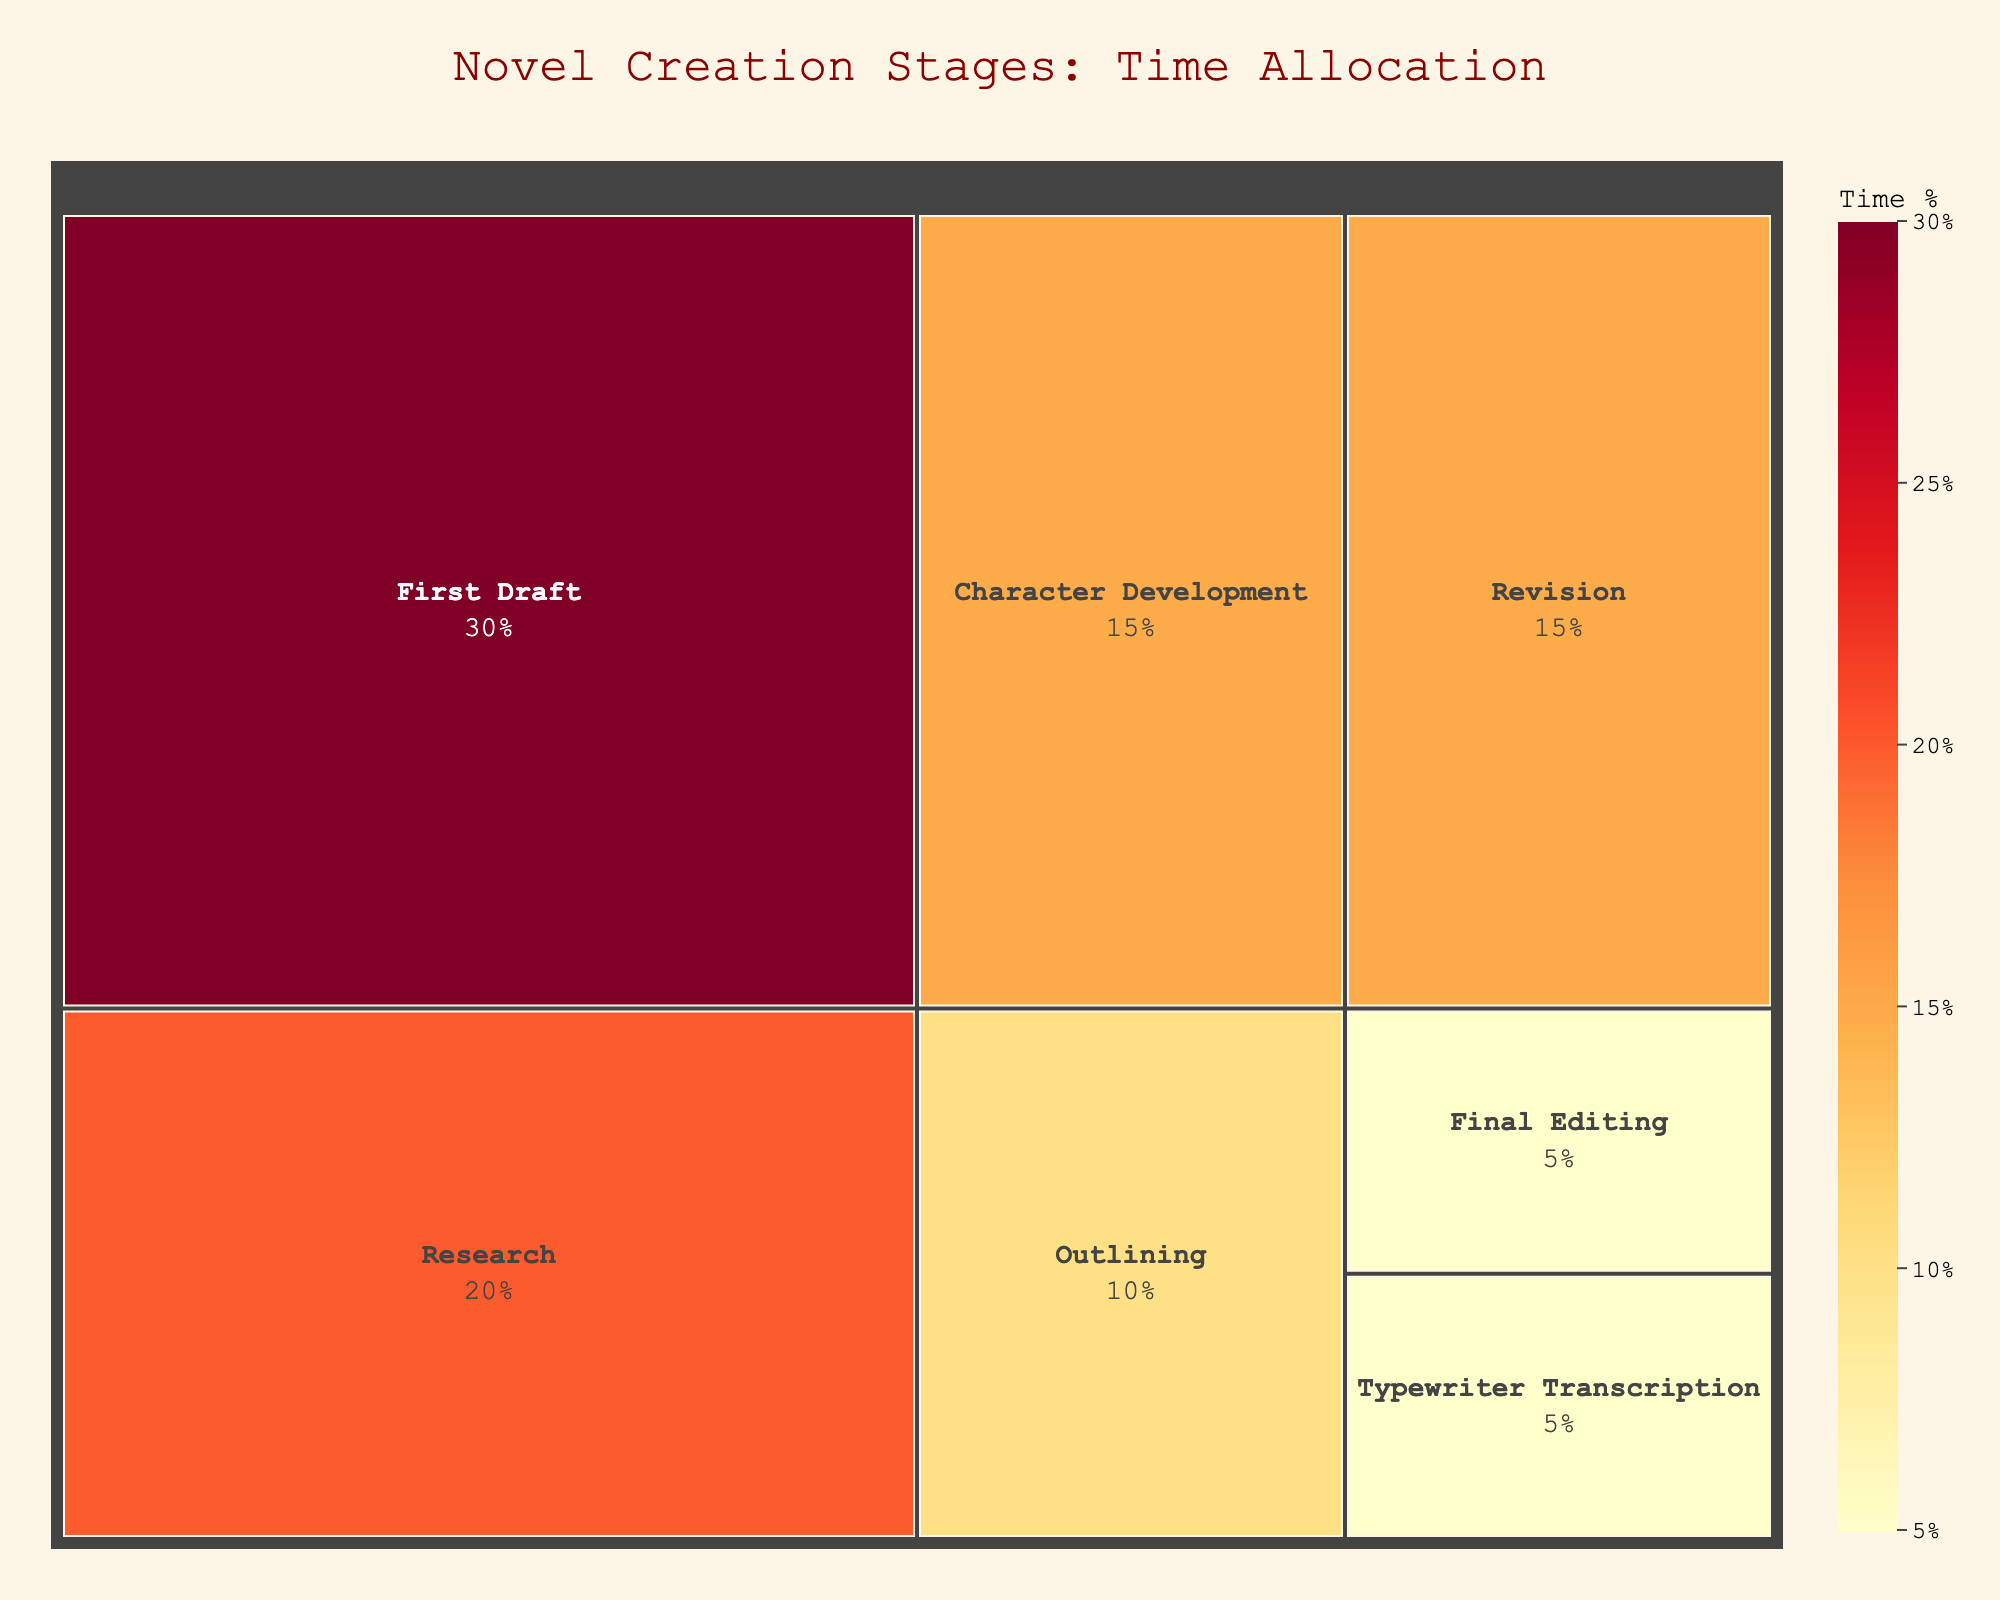What's the largest stage represented in the treemap? The largest stage can be identified visually by the area of the segment. It is the segment with the highest time allocation mentioned.
Answer: First Draft Which stages have equal time allocation? To find the stages with equal time allocation, visually compare the size of the segments or refer to the labels.
Answer: Revision and Character Development; Typewriter Transcription and Final Editing What's the total time allocated for the stages from Character Development to Final Editing? Sum the time allocations for all the stages from Character Development to Final Editing: Character Development (15%) + Outlining (10%) + First Draft (30%) + Revision (15%) + Typewriter Transcription (5%) + Final Editing (5%). This yields 15% + 10% + 30% + 15% + 5% + 5% = 80%.
Answer: 80% How does the time allocated for Research compare to Revision? Look at the segments labeled Research and Revision and their respective percentages. Research has 20% and Revision has 15%, so Research has a higher allocation.
Answer: Research has more What percentage of the novel creation process involves writing drafts (First Draft and Typewriter Transcription)? Sum the time allocations for First Draft and Typewriter Transcription: First Draft (30%) + Typewriter Transcription (5%). This yields 30% + 5% = 35%.
Answer: 35% Which stage has the smallest time allocation and what is its value? The smallest stage can be identified visually by finding the smallest segment or referring to the labels. It is the stage with the lowest percentage value.
Answer: Typewriter Transcription and Final Editing; 5% If you combine the time for Character Development and Outlining, how does it compare to the time for the First Draft? Sum Character Development and Outlining: 15% + 10% = 25%; compare this to First Draft which is 30%. Since 25% is less than 30%, the combined time is still less.
Answer: Less How many stages are there in total? Count all the segments given in the figure. Each segment represents a different stage.
Answer: 7 Is there any stage with a time allocation between 10% and 20%? Look at the segments and their respective percentages. Stages between 10% and 20% are Character Development (15%) and Revision (15%).
Answer: Yes (Character Development, Revision, and Research) 